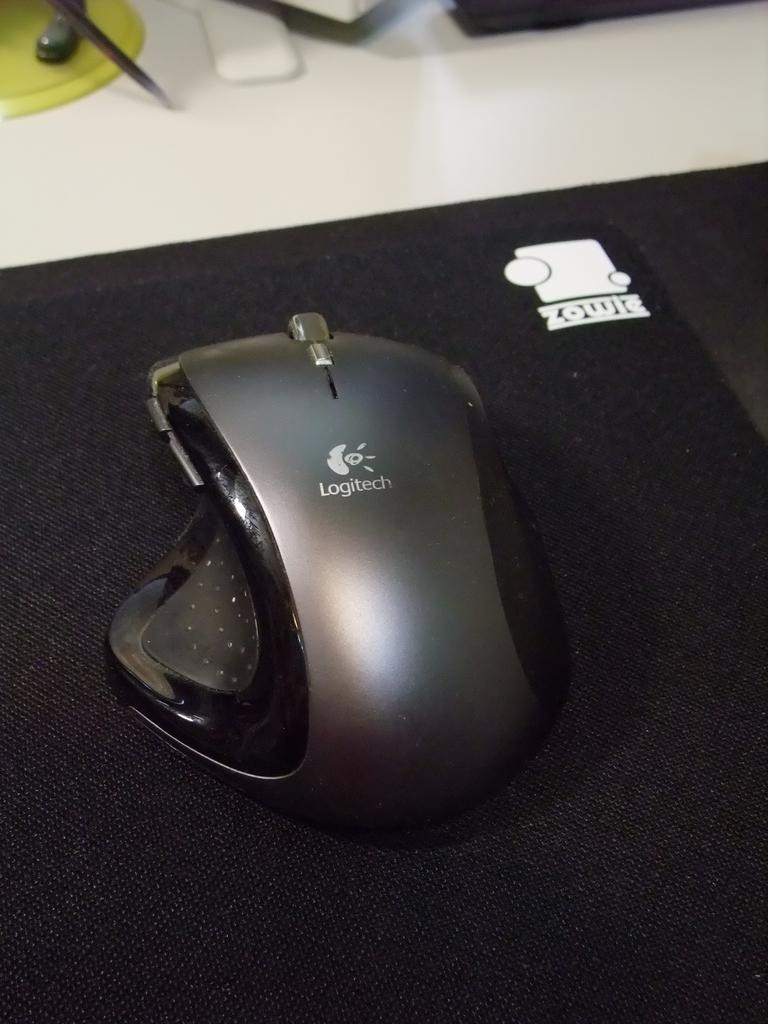What is the main subject of the image? There is a mouse in the image. Where is the mouse located? The mouse is on a mouse pad. What else can be seen in the image besides the mouse? There are objects placed on a white platform in the image. Is the mouse trying to get the attention of the toothbrush in the image? There is no toothbrush present in the image, so it cannot be determined if the mouse is trying to get its attention. 